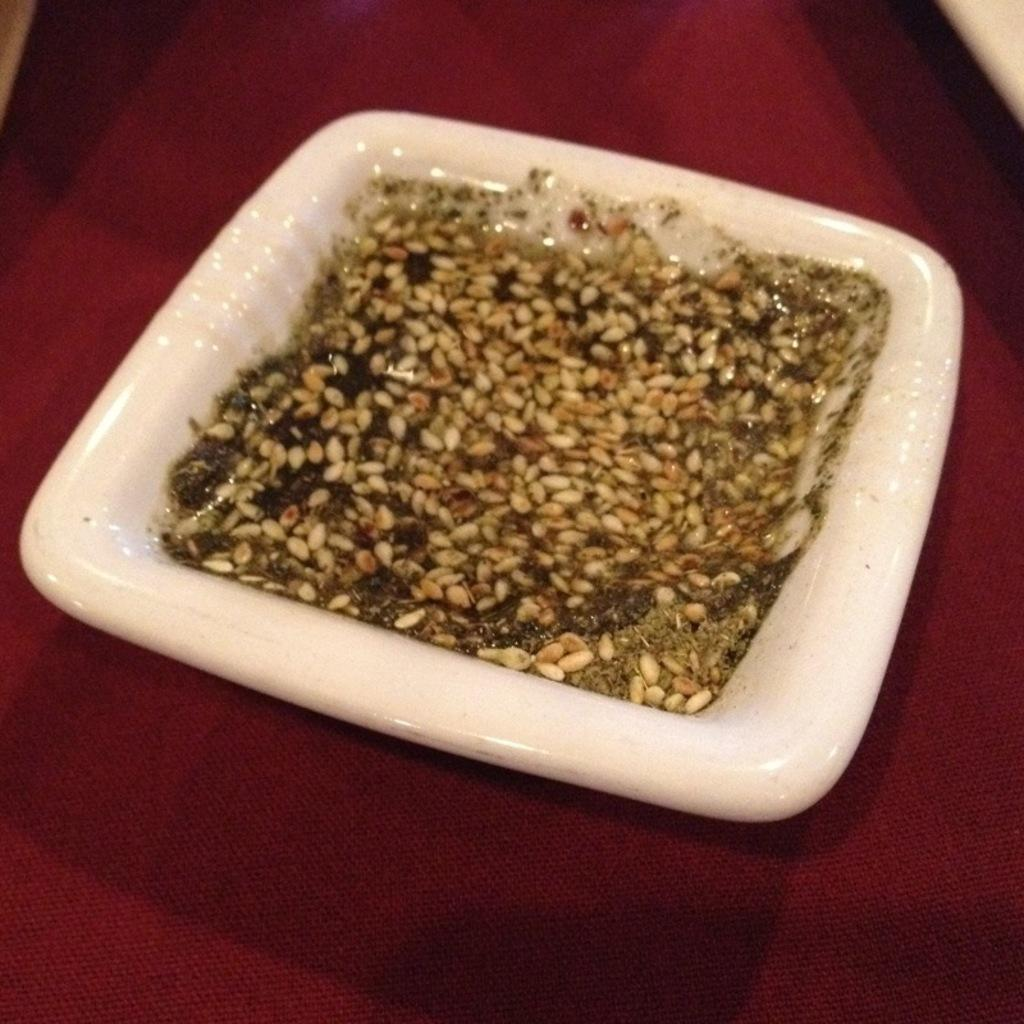What is in the bowl that is visible in the image? The bowl contains grains. What color is the bowl in the image? The bowl is white in color. What is the bowl placed on in the image? The bowl is on a red surface. Can you hear the thunder in the image? There is no mention of thunder or any sound in the image, so it cannot be heard. 